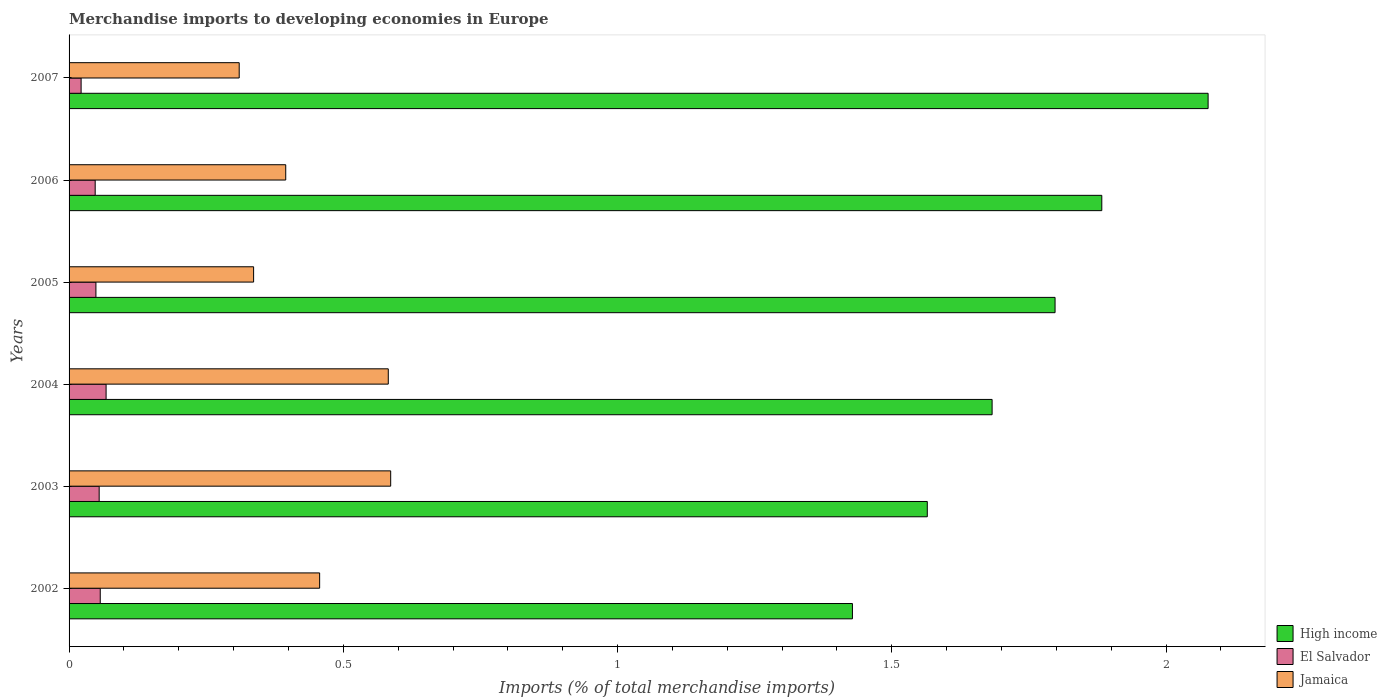How many different coloured bars are there?
Keep it short and to the point. 3. In how many cases, is the number of bars for a given year not equal to the number of legend labels?
Keep it short and to the point. 0. What is the percentage total merchandise imports in El Salvador in 2006?
Your response must be concise. 0.05. Across all years, what is the maximum percentage total merchandise imports in Jamaica?
Your answer should be compact. 0.59. Across all years, what is the minimum percentage total merchandise imports in Jamaica?
Offer a terse response. 0.31. In which year was the percentage total merchandise imports in El Salvador minimum?
Ensure brevity in your answer.  2007. What is the total percentage total merchandise imports in El Salvador in the graph?
Keep it short and to the point. 0.3. What is the difference between the percentage total merchandise imports in High income in 2002 and that in 2003?
Provide a succinct answer. -0.14. What is the difference between the percentage total merchandise imports in El Salvador in 2006 and the percentage total merchandise imports in Jamaica in 2003?
Ensure brevity in your answer.  -0.54. What is the average percentage total merchandise imports in High income per year?
Provide a short and direct response. 1.74. In the year 2002, what is the difference between the percentage total merchandise imports in High income and percentage total merchandise imports in El Salvador?
Offer a very short reply. 1.37. In how many years, is the percentage total merchandise imports in El Salvador greater than 1.5 %?
Provide a succinct answer. 0. What is the ratio of the percentage total merchandise imports in El Salvador in 2002 to that in 2006?
Make the answer very short. 1.19. Is the percentage total merchandise imports in El Salvador in 2004 less than that in 2007?
Keep it short and to the point. No. Is the difference between the percentage total merchandise imports in High income in 2005 and 2006 greater than the difference between the percentage total merchandise imports in El Salvador in 2005 and 2006?
Make the answer very short. No. What is the difference between the highest and the second highest percentage total merchandise imports in El Salvador?
Give a very brief answer. 0.01. What is the difference between the highest and the lowest percentage total merchandise imports in High income?
Provide a short and direct response. 0.65. In how many years, is the percentage total merchandise imports in High income greater than the average percentage total merchandise imports in High income taken over all years?
Ensure brevity in your answer.  3. What does the 2nd bar from the bottom in 2007 represents?
Keep it short and to the point. El Salvador. Is it the case that in every year, the sum of the percentage total merchandise imports in Jamaica and percentage total merchandise imports in High income is greater than the percentage total merchandise imports in El Salvador?
Give a very brief answer. Yes. How many bars are there?
Your answer should be very brief. 18. Are all the bars in the graph horizontal?
Offer a terse response. Yes. Where does the legend appear in the graph?
Make the answer very short. Bottom right. How many legend labels are there?
Give a very brief answer. 3. How are the legend labels stacked?
Make the answer very short. Vertical. What is the title of the graph?
Your response must be concise. Merchandise imports to developing economies in Europe. Does "Slovenia" appear as one of the legend labels in the graph?
Offer a very short reply. No. What is the label or title of the X-axis?
Provide a succinct answer. Imports (% of total merchandise imports). What is the Imports (% of total merchandise imports) in High income in 2002?
Your answer should be very brief. 1.43. What is the Imports (% of total merchandise imports) of El Salvador in 2002?
Ensure brevity in your answer.  0.06. What is the Imports (% of total merchandise imports) in Jamaica in 2002?
Provide a succinct answer. 0.46. What is the Imports (% of total merchandise imports) of High income in 2003?
Your response must be concise. 1.56. What is the Imports (% of total merchandise imports) of El Salvador in 2003?
Provide a succinct answer. 0.05. What is the Imports (% of total merchandise imports) of Jamaica in 2003?
Ensure brevity in your answer.  0.59. What is the Imports (% of total merchandise imports) in High income in 2004?
Keep it short and to the point. 1.68. What is the Imports (% of total merchandise imports) in El Salvador in 2004?
Your response must be concise. 0.07. What is the Imports (% of total merchandise imports) of Jamaica in 2004?
Offer a terse response. 0.58. What is the Imports (% of total merchandise imports) in High income in 2005?
Give a very brief answer. 1.8. What is the Imports (% of total merchandise imports) in El Salvador in 2005?
Provide a succinct answer. 0.05. What is the Imports (% of total merchandise imports) in Jamaica in 2005?
Provide a short and direct response. 0.34. What is the Imports (% of total merchandise imports) in High income in 2006?
Offer a terse response. 1.88. What is the Imports (% of total merchandise imports) in El Salvador in 2006?
Your answer should be very brief. 0.05. What is the Imports (% of total merchandise imports) in Jamaica in 2006?
Offer a terse response. 0.39. What is the Imports (% of total merchandise imports) in High income in 2007?
Your answer should be very brief. 2.08. What is the Imports (% of total merchandise imports) of El Salvador in 2007?
Provide a succinct answer. 0.02. What is the Imports (% of total merchandise imports) in Jamaica in 2007?
Your answer should be compact. 0.31. Across all years, what is the maximum Imports (% of total merchandise imports) in High income?
Offer a very short reply. 2.08. Across all years, what is the maximum Imports (% of total merchandise imports) in El Salvador?
Provide a succinct answer. 0.07. Across all years, what is the maximum Imports (% of total merchandise imports) in Jamaica?
Provide a short and direct response. 0.59. Across all years, what is the minimum Imports (% of total merchandise imports) in High income?
Keep it short and to the point. 1.43. Across all years, what is the minimum Imports (% of total merchandise imports) of El Salvador?
Your answer should be compact. 0.02. Across all years, what is the minimum Imports (% of total merchandise imports) of Jamaica?
Provide a short and direct response. 0.31. What is the total Imports (% of total merchandise imports) in High income in the graph?
Make the answer very short. 10.43. What is the total Imports (% of total merchandise imports) of El Salvador in the graph?
Ensure brevity in your answer.  0.3. What is the total Imports (% of total merchandise imports) in Jamaica in the graph?
Offer a terse response. 2.67. What is the difference between the Imports (% of total merchandise imports) in High income in 2002 and that in 2003?
Provide a succinct answer. -0.14. What is the difference between the Imports (% of total merchandise imports) of El Salvador in 2002 and that in 2003?
Offer a very short reply. 0. What is the difference between the Imports (% of total merchandise imports) of Jamaica in 2002 and that in 2003?
Offer a terse response. -0.13. What is the difference between the Imports (% of total merchandise imports) of High income in 2002 and that in 2004?
Provide a succinct answer. -0.25. What is the difference between the Imports (% of total merchandise imports) in El Salvador in 2002 and that in 2004?
Ensure brevity in your answer.  -0.01. What is the difference between the Imports (% of total merchandise imports) in Jamaica in 2002 and that in 2004?
Provide a short and direct response. -0.13. What is the difference between the Imports (% of total merchandise imports) in High income in 2002 and that in 2005?
Offer a terse response. -0.37. What is the difference between the Imports (% of total merchandise imports) of El Salvador in 2002 and that in 2005?
Ensure brevity in your answer.  0.01. What is the difference between the Imports (% of total merchandise imports) in Jamaica in 2002 and that in 2005?
Ensure brevity in your answer.  0.12. What is the difference between the Imports (% of total merchandise imports) of High income in 2002 and that in 2006?
Provide a short and direct response. -0.45. What is the difference between the Imports (% of total merchandise imports) in El Salvador in 2002 and that in 2006?
Keep it short and to the point. 0.01. What is the difference between the Imports (% of total merchandise imports) of Jamaica in 2002 and that in 2006?
Keep it short and to the point. 0.06. What is the difference between the Imports (% of total merchandise imports) of High income in 2002 and that in 2007?
Give a very brief answer. -0.65. What is the difference between the Imports (% of total merchandise imports) of El Salvador in 2002 and that in 2007?
Your response must be concise. 0.03. What is the difference between the Imports (% of total merchandise imports) in Jamaica in 2002 and that in 2007?
Keep it short and to the point. 0.15. What is the difference between the Imports (% of total merchandise imports) in High income in 2003 and that in 2004?
Provide a short and direct response. -0.12. What is the difference between the Imports (% of total merchandise imports) in El Salvador in 2003 and that in 2004?
Offer a very short reply. -0.01. What is the difference between the Imports (% of total merchandise imports) in Jamaica in 2003 and that in 2004?
Make the answer very short. 0. What is the difference between the Imports (% of total merchandise imports) of High income in 2003 and that in 2005?
Your answer should be compact. -0.23. What is the difference between the Imports (% of total merchandise imports) in El Salvador in 2003 and that in 2005?
Provide a short and direct response. 0.01. What is the difference between the Imports (% of total merchandise imports) of Jamaica in 2003 and that in 2005?
Your answer should be compact. 0.25. What is the difference between the Imports (% of total merchandise imports) of High income in 2003 and that in 2006?
Provide a succinct answer. -0.32. What is the difference between the Imports (% of total merchandise imports) in El Salvador in 2003 and that in 2006?
Keep it short and to the point. 0.01. What is the difference between the Imports (% of total merchandise imports) in Jamaica in 2003 and that in 2006?
Offer a very short reply. 0.19. What is the difference between the Imports (% of total merchandise imports) of High income in 2003 and that in 2007?
Give a very brief answer. -0.51. What is the difference between the Imports (% of total merchandise imports) of El Salvador in 2003 and that in 2007?
Keep it short and to the point. 0.03. What is the difference between the Imports (% of total merchandise imports) in Jamaica in 2003 and that in 2007?
Provide a short and direct response. 0.28. What is the difference between the Imports (% of total merchandise imports) of High income in 2004 and that in 2005?
Ensure brevity in your answer.  -0.11. What is the difference between the Imports (% of total merchandise imports) of El Salvador in 2004 and that in 2005?
Keep it short and to the point. 0.02. What is the difference between the Imports (% of total merchandise imports) of Jamaica in 2004 and that in 2005?
Offer a terse response. 0.25. What is the difference between the Imports (% of total merchandise imports) in High income in 2004 and that in 2006?
Make the answer very short. -0.2. What is the difference between the Imports (% of total merchandise imports) of El Salvador in 2004 and that in 2006?
Your answer should be very brief. 0.02. What is the difference between the Imports (% of total merchandise imports) in Jamaica in 2004 and that in 2006?
Offer a very short reply. 0.19. What is the difference between the Imports (% of total merchandise imports) of High income in 2004 and that in 2007?
Keep it short and to the point. -0.39. What is the difference between the Imports (% of total merchandise imports) of El Salvador in 2004 and that in 2007?
Offer a very short reply. 0.05. What is the difference between the Imports (% of total merchandise imports) in Jamaica in 2004 and that in 2007?
Your response must be concise. 0.27. What is the difference between the Imports (% of total merchandise imports) in High income in 2005 and that in 2006?
Make the answer very short. -0.09. What is the difference between the Imports (% of total merchandise imports) of El Salvador in 2005 and that in 2006?
Keep it short and to the point. 0. What is the difference between the Imports (% of total merchandise imports) of Jamaica in 2005 and that in 2006?
Give a very brief answer. -0.06. What is the difference between the Imports (% of total merchandise imports) in High income in 2005 and that in 2007?
Your answer should be very brief. -0.28. What is the difference between the Imports (% of total merchandise imports) in El Salvador in 2005 and that in 2007?
Provide a short and direct response. 0.03. What is the difference between the Imports (% of total merchandise imports) of Jamaica in 2005 and that in 2007?
Offer a very short reply. 0.03. What is the difference between the Imports (% of total merchandise imports) in High income in 2006 and that in 2007?
Provide a short and direct response. -0.19. What is the difference between the Imports (% of total merchandise imports) in El Salvador in 2006 and that in 2007?
Provide a succinct answer. 0.03. What is the difference between the Imports (% of total merchandise imports) of Jamaica in 2006 and that in 2007?
Your answer should be compact. 0.08. What is the difference between the Imports (% of total merchandise imports) of High income in 2002 and the Imports (% of total merchandise imports) of El Salvador in 2003?
Make the answer very short. 1.37. What is the difference between the Imports (% of total merchandise imports) of High income in 2002 and the Imports (% of total merchandise imports) of Jamaica in 2003?
Your response must be concise. 0.84. What is the difference between the Imports (% of total merchandise imports) in El Salvador in 2002 and the Imports (% of total merchandise imports) in Jamaica in 2003?
Keep it short and to the point. -0.53. What is the difference between the Imports (% of total merchandise imports) of High income in 2002 and the Imports (% of total merchandise imports) of El Salvador in 2004?
Make the answer very short. 1.36. What is the difference between the Imports (% of total merchandise imports) in High income in 2002 and the Imports (% of total merchandise imports) in Jamaica in 2004?
Provide a short and direct response. 0.85. What is the difference between the Imports (% of total merchandise imports) in El Salvador in 2002 and the Imports (% of total merchandise imports) in Jamaica in 2004?
Provide a short and direct response. -0.53. What is the difference between the Imports (% of total merchandise imports) of High income in 2002 and the Imports (% of total merchandise imports) of El Salvador in 2005?
Offer a very short reply. 1.38. What is the difference between the Imports (% of total merchandise imports) of High income in 2002 and the Imports (% of total merchandise imports) of Jamaica in 2005?
Your answer should be very brief. 1.09. What is the difference between the Imports (% of total merchandise imports) in El Salvador in 2002 and the Imports (% of total merchandise imports) in Jamaica in 2005?
Provide a short and direct response. -0.28. What is the difference between the Imports (% of total merchandise imports) in High income in 2002 and the Imports (% of total merchandise imports) in El Salvador in 2006?
Your answer should be compact. 1.38. What is the difference between the Imports (% of total merchandise imports) in High income in 2002 and the Imports (% of total merchandise imports) in Jamaica in 2006?
Give a very brief answer. 1.03. What is the difference between the Imports (% of total merchandise imports) of El Salvador in 2002 and the Imports (% of total merchandise imports) of Jamaica in 2006?
Make the answer very short. -0.34. What is the difference between the Imports (% of total merchandise imports) in High income in 2002 and the Imports (% of total merchandise imports) in El Salvador in 2007?
Offer a terse response. 1.41. What is the difference between the Imports (% of total merchandise imports) of High income in 2002 and the Imports (% of total merchandise imports) of Jamaica in 2007?
Provide a succinct answer. 1.12. What is the difference between the Imports (% of total merchandise imports) in El Salvador in 2002 and the Imports (% of total merchandise imports) in Jamaica in 2007?
Your answer should be compact. -0.25. What is the difference between the Imports (% of total merchandise imports) of High income in 2003 and the Imports (% of total merchandise imports) of El Salvador in 2004?
Provide a succinct answer. 1.5. What is the difference between the Imports (% of total merchandise imports) in High income in 2003 and the Imports (% of total merchandise imports) in Jamaica in 2004?
Provide a short and direct response. 0.98. What is the difference between the Imports (% of total merchandise imports) of El Salvador in 2003 and the Imports (% of total merchandise imports) of Jamaica in 2004?
Provide a succinct answer. -0.53. What is the difference between the Imports (% of total merchandise imports) of High income in 2003 and the Imports (% of total merchandise imports) of El Salvador in 2005?
Offer a very short reply. 1.52. What is the difference between the Imports (% of total merchandise imports) in High income in 2003 and the Imports (% of total merchandise imports) in Jamaica in 2005?
Your answer should be compact. 1.23. What is the difference between the Imports (% of total merchandise imports) of El Salvador in 2003 and the Imports (% of total merchandise imports) of Jamaica in 2005?
Offer a very short reply. -0.28. What is the difference between the Imports (% of total merchandise imports) of High income in 2003 and the Imports (% of total merchandise imports) of El Salvador in 2006?
Make the answer very short. 1.52. What is the difference between the Imports (% of total merchandise imports) of High income in 2003 and the Imports (% of total merchandise imports) of Jamaica in 2006?
Provide a short and direct response. 1.17. What is the difference between the Imports (% of total merchandise imports) in El Salvador in 2003 and the Imports (% of total merchandise imports) in Jamaica in 2006?
Your response must be concise. -0.34. What is the difference between the Imports (% of total merchandise imports) in High income in 2003 and the Imports (% of total merchandise imports) in El Salvador in 2007?
Your answer should be compact. 1.54. What is the difference between the Imports (% of total merchandise imports) of High income in 2003 and the Imports (% of total merchandise imports) of Jamaica in 2007?
Your answer should be compact. 1.25. What is the difference between the Imports (% of total merchandise imports) in El Salvador in 2003 and the Imports (% of total merchandise imports) in Jamaica in 2007?
Keep it short and to the point. -0.26. What is the difference between the Imports (% of total merchandise imports) in High income in 2004 and the Imports (% of total merchandise imports) in El Salvador in 2005?
Offer a terse response. 1.63. What is the difference between the Imports (% of total merchandise imports) in High income in 2004 and the Imports (% of total merchandise imports) in Jamaica in 2005?
Give a very brief answer. 1.35. What is the difference between the Imports (% of total merchandise imports) in El Salvador in 2004 and the Imports (% of total merchandise imports) in Jamaica in 2005?
Provide a succinct answer. -0.27. What is the difference between the Imports (% of total merchandise imports) in High income in 2004 and the Imports (% of total merchandise imports) in El Salvador in 2006?
Make the answer very short. 1.64. What is the difference between the Imports (% of total merchandise imports) in High income in 2004 and the Imports (% of total merchandise imports) in Jamaica in 2006?
Give a very brief answer. 1.29. What is the difference between the Imports (% of total merchandise imports) in El Salvador in 2004 and the Imports (% of total merchandise imports) in Jamaica in 2006?
Make the answer very short. -0.33. What is the difference between the Imports (% of total merchandise imports) in High income in 2004 and the Imports (% of total merchandise imports) in El Salvador in 2007?
Give a very brief answer. 1.66. What is the difference between the Imports (% of total merchandise imports) of High income in 2004 and the Imports (% of total merchandise imports) of Jamaica in 2007?
Keep it short and to the point. 1.37. What is the difference between the Imports (% of total merchandise imports) in El Salvador in 2004 and the Imports (% of total merchandise imports) in Jamaica in 2007?
Keep it short and to the point. -0.24. What is the difference between the Imports (% of total merchandise imports) in High income in 2005 and the Imports (% of total merchandise imports) in El Salvador in 2006?
Provide a succinct answer. 1.75. What is the difference between the Imports (% of total merchandise imports) of High income in 2005 and the Imports (% of total merchandise imports) of Jamaica in 2006?
Make the answer very short. 1.4. What is the difference between the Imports (% of total merchandise imports) in El Salvador in 2005 and the Imports (% of total merchandise imports) in Jamaica in 2006?
Provide a short and direct response. -0.35. What is the difference between the Imports (% of total merchandise imports) in High income in 2005 and the Imports (% of total merchandise imports) in El Salvador in 2007?
Give a very brief answer. 1.78. What is the difference between the Imports (% of total merchandise imports) of High income in 2005 and the Imports (% of total merchandise imports) of Jamaica in 2007?
Make the answer very short. 1.49. What is the difference between the Imports (% of total merchandise imports) of El Salvador in 2005 and the Imports (% of total merchandise imports) of Jamaica in 2007?
Your answer should be compact. -0.26. What is the difference between the Imports (% of total merchandise imports) of High income in 2006 and the Imports (% of total merchandise imports) of El Salvador in 2007?
Make the answer very short. 1.86. What is the difference between the Imports (% of total merchandise imports) in High income in 2006 and the Imports (% of total merchandise imports) in Jamaica in 2007?
Provide a succinct answer. 1.57. What is the difference between the Imports (% of total merchandise imports) of El Salvador in 2006 and the Imports (% of total merchandise imports) of Jamaica in 2007?
Your answer should be compact. -0.26. What is the average Imports (% of total merchandise imports) in High income per year?
Your answer should be compact. 1.74. What is the average Imports (% of total merchandise imports) of El Salvador per year?
Give a very brief answer. 0.05. What is the average Imports (% of total merchandise imports) in Jamaica per year?
Give a very brief answer. 0.44. In the year 2002, what is the difference between the Imports (% of total merchandise imports) of High income and Imports (% of total merchandise imports) of El Salvador?
Provide a succinct answer. 1.37. In the year 2002, what is the difference between the Imports (% of total merchandise imports) of High income and Imports (% of total merchandise imports) of Jamaica?
Your answer should be compact. 0.97. In the year 2002, what is the difference between the Imports (% of total merchandise imports) of El Salvador and Imports (% of total merchandise imports) of Jamaica?
Ensure brevity in your answer.  -0.4. In the year 2003, what is the difference between the Imports (% of total merchandise imports) in High income and Imports (% of total merchandise imports) in El Salvador?
Keep it short and to the point. 1.51. In the year 2003, what is the difference between the Imports (% of total merchandise imports) in High income and Imports (% of total merchandise imports) in Jamaica?
Offer a very short reply. 0.98. In the year 2003, what is the difference between the Imports (% of total merchandise imports) in El Salvador and Imports (% of total merchandise imports) in Jamaica?
Provide a short and direct response. -0.53. In the year 2004, what is the difference between the Imports (% of total merchandise imports) of High income and Imports (% of total merchandise imports) of El Salvador?
Give a very brief answer. 1.62. In the year 2004, what is the difference between the Imports (% of total merchandise imports) of High income and Imports (% of total merchandise imports) of Jamaica?
Ensure brevity in your answer.  1.1. In the year 2004, what is the difference between the Imports (% of total merchandise imports) in El Salvador and Imports (% of total merchandise imports) in Jamaica?
Offer a terse response. -0.51. In the year 2005, what is the difference between the Imports (% of total merchandise imports) in High income and Imports (% of total merchandise imports) in El Salvador?
Provide a short and direct response. 1.75. In the year 2005, what is the difference between the Imports (% of total merchandise imports) of High income and Imports (% of total merchandise imports) of Jamaica?
Give a very brief answer. 1.46. In the year 2005, what is the difference between the Imports (% of total merchandise imports) of El Salvador and Imports (% of total merchandise imports) of Jamaica?
Your response must be concise. -0.29. In the year 2006, what is the difference between the Imports (% of total merchandise imports) in High income and Imports (% of total merchandise imports) in El Salvador?
Offer a terse response. 1.84. In the year 2006, what is the difference between the Imports (% of total merchandise imports) of High income and Imports (% of total merchandise imports) of Jamaica?
Keep it short and to the point. 1.49. In the year 2006, what is the difference between the Imports (% of total merchandise imports) of El Salvador and Imports (% of total merchandise imports) of Jamaica?
Offer a terse response. -0.35. In the year 2007, what is the difference between the Imports (% of total merchandise imports) of High income and Imports (% of total merchandise imports) of El Salvador?
Provide a succinct answer. 2.05. In the year 2007, what is the difference between the Imports (% of total merchandise imports) in High income and Imports (% of total merchandise imports) in Jamaica?
Offer a very short reply. 1.77. In the year 2007, what is the difference between the Imports (% of total merchandise imports) of El Salvador and Imports (% of total merchandise imports) of Jamaica?
Make the answer very short. -0.29. What is the ratio of the Imports (% of total merchandise imports) in High income in 2002 to that in 2003?
Keep it short and to the point. 0.91. What is the ratio of the Imports (% of total merchandise imports) in El Salvador in 2002 to that in 2003?
Give a very brief answer. 1.04. What is the ratio of the Imports (% of total merchandise imports) of Jamaica in 2002 to that in 2003?
Make the answer very short. 0.78. What is the ratio of the Imports (% of total merchandise imports) in High income in 2002 to that in 2004?
Offer a terse response. 0.85. What is the ratio of the Imports (% of total merchandise imports) of El Salvador in 2002 to that in 2004?
Your answer should be very brief. 0.84. What is the ratio of the Imports (% of total merchandise imports) of Jamaica in 2002 to that in 2004?
Your answer should be compact. 0.79. What is the ratio of the Imports (% of total merchandise imports) of High income in 2002 to that in 2005?
Keep it short and to the point. 0.79. What is the ratio of the Imports (% of total merchandise imports) of El Salvador in 2002 to that in 2005?
Your answer should be very brief. 1.16. What is the ratio of the Imports (% of total merchandise imports) of Jamaica in 2002 to that in 2005?
Provide a succinct answer. 1.36. What is the ratio of the Imports (% of total merchandise imports) of High income in 2002 to that in 2006?
Your response must be concise. 0.76. What is the ratio of the Imports (% of total merchandise imports) of El Salvador in 2002 to that in 2006?
Make the answer very short. 1.19. What is the ratio of the Imports (% of total merchandise imports) in Jamaica in 2002 to that in 2006?
Provide a succinct answer. 1.16. What is the ratio of the Imports (% of total merchandise imports) of High income in 2002 to that in 2007?
Your answer should be very brief. 0.69. What is the ratio of the Imports (% of total merchandise imports) in El Salvador in 2002 to that in 2007?
Give a very brief answer. 2.59. What is the ratio of the Imports (% of total merchandise imports) of Jamaica in 2002 to that in 2007?
Make the answer very short. 1.47. What is the ratio of the Imports (% of total merchandise imports) in High income in 2003 to that in 2004?
Make the answer very short. 0.93. What is the ratio of the Imports (% of total merchandise imports) in El Salvador in 2003 to that in 2004?
Ensure brevity in your answer.  0.81. What is the ratio of the Imports (% of total merchandise imports) of Jamaica in 2003 to that in 2004?
Your answer should be very brief. 1.01. What is the ratio of the Imports (% of total merchandise imports) in High income in 2003 to that in 2005?
Your answer should be compact. 0.87. What is the ratio of the Imports (% of total merchandise imports) of El Salvador in 2003 to that in 2005?
Your answer should be very brief. 1.12. What is the ratio of the Imports (% of total merchandise imports) of Jamaica in 2003 to that in 2005?
Your answer should be very brief. 1.74. What is the ratio of the Imports (% of total merchandise imports) of High income in 2003 to that in 2006?
Offer a terse response. 0.83. What is the ratio of the Imports (% of total merchandise imports) in El Salvador in 2003 to that in 2006?
Provide a short and direct response. 1.15. What is the ratio of the Imports (% of total merchandise imports) of Jamaica in 2003 to that in 2006?
Provide a succinct answer. 1.48. What is the ratio of the Imports (% of total merchandise imports) of High income in 2003 to that in 2007?
Provide a short and direct response. 0.75. What is the ratio of the Imports (% of total merchandise imports) of El Salvador in 2003 to that in 2007?
Offer a terse response. 2.5. What is the ratio of the Imports (% of total merchandise imports) of Jamaica in 2003 to that in 2007?
Your answer should be compact. 1.89. What is the ratio of the Imports (% of total merchandise imports) of High income in 2004 to that in 2005?
Keep it short and to the point. 0.94. What is the ratio of the Imports (% of total merchandise imports) of El Salvador in 2004 to that in 2005?
Offer a terse response. 1.38. What is the ratio of the Imports (% of total merchandise imports) in Jamaica in 2004 to that in 2005?
Offer a very short reply. 1.73. What is the ratio of the Imports (% of total merchandise imports) of High income in 2004 to that in 2006?
Ensure brevity in your answer.  0.89. What is the ratio of the Imports (% of total merchandise imports) of El Salvador in 2004 to that in 2006?
Offer a very short reply. 1.42. What is the ratio of the Imports (% of total merchandise imports) of Jamaica in 2004 to that in 2006?
Give a very brief answer. 1.47. What is the ratio of the Imports (% of total merchandise imports) of High income in 2004 to that in 2007?
Provide a short and direct response. 0.81. What is the ratio of the Imports (% of total merchandise imports) in El Salvador in 2004 to that in 2007?
Keep it short and to the point. 3.08. What is the ratio of the Imports (% of total merchandise imports) of Jamaica in 2004 to that in 2007?
Your response must be concise. 1.88. What is the ratio of the Imports (% of total merchandise imports) of High income in 2005 to that in 2006?
Give a very brief answer. 0.95. What is the ratio of the Imports (% of total merchandise imports) in El Salvador in 2005 to that in 2006?
Make the answer very short. 1.03. What is the ratio of the Imports (% of total merchandise imports) of Jamaica in 2005 to that in 2006?
Your answer should be very brief. 0.85. What is the ratio of the Imports (% of total merchandise imports) in High income in 2005 to that in 2007?
Ensure brevity in your answer.  0.87. What is the ratio of the Imports (% of total merchandise imports) in El Salvador in 2005 to that in 2007?
Your answer should be very brief. 2.23. What is the ratio of the Imports (% of total merchandise imports) in Jamaica in 2005 to that in 2007?
Offer a very short reply. 1.08. What is the ratio of the Imports (% of total merchandise imports) of High income in 2006 to that in 2007?
Provide a succinct answer. 0.91. What is the ratio of the Imports (% of total merchandise imports) in El Salvador in 2006 to that in 2007?
Your answer should be very brief. 2.17. What is the ratio of the Imports (% of total merchandise imports) in Jamaica in 2006 to that in 2007?
Provide a short and direct response. 1.27. What is the difference between the highest and the second highest Imports (% of total merchandise imports) in High income?
Your response must be concise. 0.19. What is the difference between the highest and the second highest Imports (% of total merchandise imports) of El Salvador?
Your answer should be compact. 0.01. What is the difference between the highest and the second highest Imports (% of total merchandise imports) in Jamaica?
Give a very brief answer. 0. What is the difference between the highest and the lowest Imports (% of total merchandise imports) in High income?
Your answer should be very brief. 0.65. What is the difference between the highest and the lowest Imports (% of total merchandise imports) in El Salvador?
Your response must be concise. 0.05. What is the difference between the highest and the lowest Imports (% of total merchandise imports) of Jamaica?
Offer a very short reply. 0.28. 